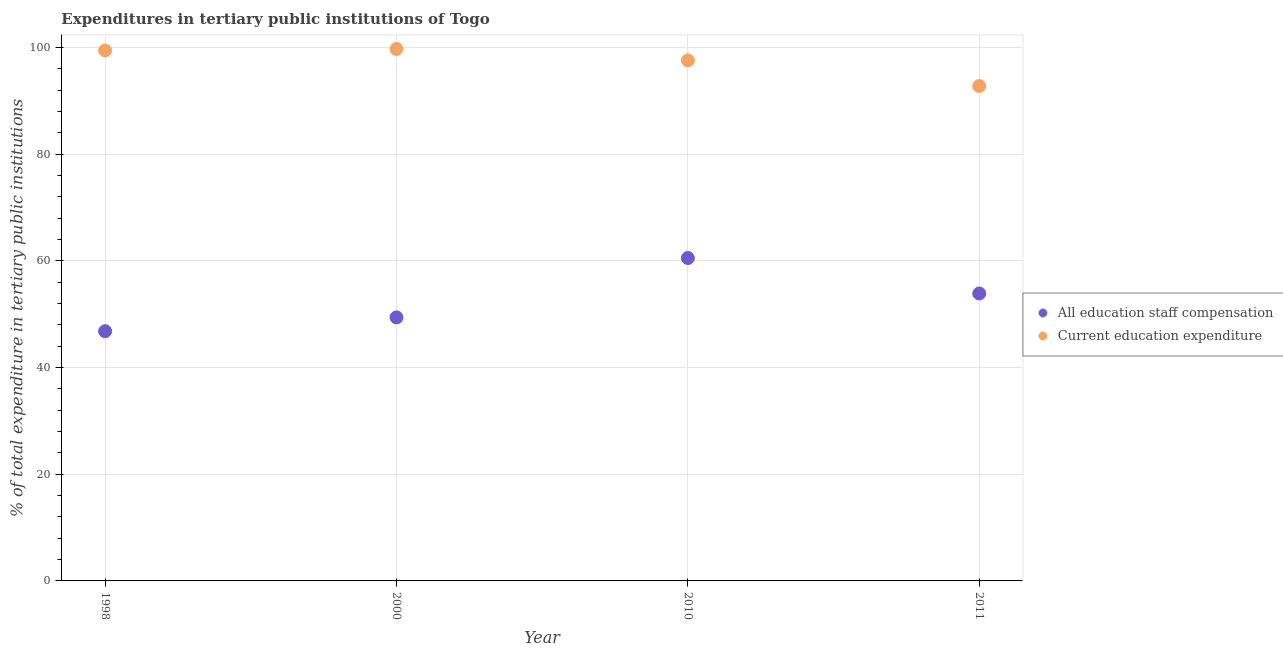What is the expenditure in education in 2000?
Ensure brevity in your answer.  99.72. Across all years, what is the maximum expenditure in education?
Ensure brevity in your answer.  99.72. Across all years, what is the minimum expenditure in education?
Your answer should be compact. 92.78. In which year was the expenditure in education maximum?
Keep it short and to the point. 2000. What is the total expenditure in staff compensation in the graph?
Ensure brevity in your answer.  210.64. What is the difference between the expenditure in staff compensation in 1998 and that in 2000?
Your response must be concise. -2.59. What is the difference between the expenditure in staff compensation in 2010 and the expenditure in education in 1998?
Your answer should be compact. -38.91. What is the average expenditure in education per year?
Your answer should be compact. 97.38. In the year 2010, what is the difference between the expenditure in staff compensation and expenditure in education?
Keep it short and to the point. -37.06. In how many years, is the expenditure in education greater than 88 %?
Give a very brief answer. 4. What is the ratio of the expenditure in staff compensation in 2000 to that in 2011?
Offer a very short reply. 0.92. Is the difference between the expenditure in education in 1998 and 2000 greater than the difference between the expenditure in staff compensation in 1998 and 2000?
Your answer should be compact. Yes. What is the difference between the highest and the second highest expenditure in education?
Your answer should be compact. 0.28. What is the difference between the highest and the lowest expenditure in education?
Ensure brevity in your answer.  6.95. Is the sum of the expenditure in education in 2000 and 2010 greater than the maximum expenditure in staff compensation across all years?
Make the answer very short. Yes. Is the expenditure in education strictly greater than the expenditure in staff compensation over the years?
Give a very brief answer. Yes. What is the difference between two consecutive major ticks on the Y-axis?
Make the answer very short. 20. Are the values on the major ticks of Y-axis written in scientific E-notation?
Your answer should be compact. No. Does the graph contain any zero values?
Make the answer very short. No. Does the graph contain grids?
Give a very brief answer. Yes. What is the title of the graph?
Your response must be concise. Expenditures in tertiary public institutions of Togo. Does "Private funds" appear as one of the legend labels in the graph?
Provide a short and direct response. No. What is the label or title of the Y-axis?
Offer a very short reply. % of total expenditure in tertiary public institutions. What is the % of total expenditure in tertiary public institutions in All education staff compensation in 1998?
Keep it short and to the point. 46.81. What is the % of total expenditure in tertiary public institutions of Current education expenditure in 1998?
Provide a short and direct response. 99.45. What is the % of total expenditure in tertiary public institutions in All education staff compensation in 2000?
Give a very brief answer. 49.4. What is the % of total expenditure in tertiary public institutions in Current education expenditure in 2000?
Give a very brief answer. 99.72. What is the % of total expenditure in tertiary public institutions of All education staff compensation in 2010?
Give a very brief answer. 60.53. What is the % of total expenditure in tertiary public institutions in Current education expenditure in 2010?
Offer a terse response. 97.59. What is the % of total expenditure in tertiary public institutions in All education staff compensation in 2011?
Provide a short and direct response. 53.89. What is the % of total expenditure in tertiary public institutions of Current education expenditure in 2011?
Your response must be concise. 92.78. Across all years, what is the maximum % of total expenditure in tertiary public institutions in All education staff compensation?
Offer a terse response. 60.53. Across all years, what is the maximum % of total expenditure in tertiary public institutions in Current education expenditure?
Your response must be concise. 99.72. Across all years, what is the minimum % of total expenditure in tertiary public institutions of All education staff compensation?
Your response must be concise. 46.81. Across all years, what is the minimum % of total expenditure in tertiary public institutions of Current education expenditure?
Give a very brief answer. 92.78. What is the total % of total expenditure in tertiary public institutions in All education staff compensation in the graph?
Your response must be concise. 210.64. What is the total % of total expenditure in tertiary public institutions in Current education expenditure in the graph?
Give a very brief answer. 389.54. What is the difference between the % of total expenditure in tertiary public institutions in All education staff compensation in 1998 and that in 2000?
Offer a very short reply. -2.59. What is the difference between the % of total expenditure in tertiary public institutions in Current education expenditure in 1998 and that in 2000?
Your response must be concise. -0.28. What is the difference between the % of total expenditure in tertiary public institutions in All education staff compensation in 1998 and that in 2010?
Your answer should be compact. -13.72. What is the difference between the % of total expenditure in tertiary public institutions of Current education expenditure in 1998 and that in 2010?
Make the answer very short. 1.85. What is the difference between the % of total expenditure in tertiary public institutions in All education staff compensation in 1998 and that in 2011?
Your answer should be compact. -7.08. What is the difference between the % of total expenditure in tertiary public institutions of Current education expenditure in 1998 and that in 2011?
Keep it short and to the point. 6.67. What is the difference between the % of total expenditure in tertiary public institutions of All education staff compensation in 2000 and that in 2010?
Ensure brevity in your answer.  -11.13. What is the difference between the % of total expenditure in tertiary public institutions in Current education expenditure in 2000 and that in 2010?
Offer a terse response. 2.13. What is the difference between the % of total expenditure in tertiary public institutions of All education staff compensation in 2000 and that in 2011?
Keep it short and to the point. -4.48. What is the difference between the % of total expenditure in tertiary public institutions of Current education expenditure in 2000 and that in 2011?
Offer a terse response. 6.95. What is the difference between the % of total expenditure in tertiary public institutions of All education staff compensation in 2010 and that in 2011?
Your response must be concise. 6.64. What is the difference between the % of total expenditure in tertiary public institutions in Current education expenditure in 2010 and that in 2011?
Provide a short and direct response. 4.81. What is the difference between the % of total expenditure in tertiary public institutions of All education staff compensation in 1998 and the % of total expenditure in tertiary public institutions of Current education expenditure in 2000?
Your answer should be very brief. -52.91. What is the difference between the % of total expenditure in tertiary public institutions in All education staff compensation in 1998 and the % of total expenditure in tertiary public institutions in Current education expenditure in 2010?
Give a very brief answer. -50.78. What is the difference between the % of total expenditure in tertiary public institutions of All education staff compensation in 1998 and the % of total expenditure in tertiary public institutions of Current education expenditure in 2011?
Ensure brevity in your answer.  -45.97. What is the difference between the % of total expenditure in tertiary public institutions in All education staff compensation in 2000 and the % of total expenditure in tertiary public institutions in Current education expenditure in 2010?
Ensure brevity in your answer.  -48.19. What is the difference between the % of total expenditure in tertiary public institutions in All education staff compensation in 2000 and the % of total expenditure in tertiary public institutions in Current education expenditure in 2011?
Make the answer very short. -43.37. What is the difference between the % of total expenditure in tertiary public institutions of All education staff compensation in 2010 and the % of total expenditure in tertiary public institutions of Current education expenditure in 2011?
Your answer should be compact. -32.24. What is the average % of total expenditure in tertiary public institutions of All education staff compensation per year?
Provide a succinct answer. 52.66. What is the average % of total expenditure in tertiary public institutions in Current education expenditure per year?
Your answer should be very brief. 97.38. In the year 1998, what is the difference between the % of total expenditure in tertiary public institutions in All education staff compensation and % of total expenditure in tertiary public institutions in Current education expenditure?
Provide a short and direct response. -52.63. In the year 2000, what is the difference between the % of total expenditure in tertiary public institutions in All education staff compensation and % of total expenditure in tertiary public institutions in Current education expenditure?
Keep it short and to the point. -50.32. In the year 2010, what is the difference between the % of total expenditure in tertiary public institutions in All education staff compensation and % of total expenditure in tertiary public institutions in Current education expenditure?
Your response must be concise. -37.06. In the year 2011, what is the difference between the % of total expenditure in tertiary public institutions of All education staff compensation and % of total expenditure in tertiary public institutions of Current education expenditure?
Provide a short and direct response. -38.89. What is the ratio of the % of total expenditure in tertiary public institutions of All education staff compensation in 1998 to that in 2000?
Give a very brief answer. 0.95. What is the ratio of the % of total expenditure in tertiary public institutions of Current education expenditure in 1998 to that in 2000?
Offer a terse response. 1. What is the ratio of the % of total expenditure in tertiary public institutions of All education staff compensation in 1998 to that in 2010?
Provide a succinct answer. 0.77. What is the ratio of the % of total expenditure in tertiary public institutions of Current education expenditure in 1998 to that in 2010?
Offer a very short reply. 1.02. What is the ratio of the % of total expenditure in tertiary public institutions of All education staff compensation in 1998 to that in 2011?
Ensure brevity in your answer.  0.87. What is the ratio of the % of total expenditure in tertiary public institutions of Current education expenditure in 1998 to that in 2011?
Your answer should be compact. 1.07. What is the ratio of the % of total expenditure in tertiary public institutions in All education staff compensation in 2000 to that in 2010?
Keep it short and to the point. 0.82. What is the ratio of the % of total expenditure in tertiary public institutions of Current education expenditure in 2000 to that in 2010?
Your response must be concise. 1.02. What is the ratio of the % of total expenditure in tertiary public institutions of All education staff compensation in 2000 to that in 2011?
Provide a short and direct response. 0.92. What is the ratio of the % of total expenditure in tertiary public institutions of Current education expenditure in 2000 to that in 2011?
Your answer should be compact. 1.07. What is the ratio of the % of total expenditure in tertiary public institutions of All education staff compensation in 2010 to that in 2011?
Offer a terse response. 1.12. What is the ratio of the % of total expenditure in tertiary public institutions of Current education expenditure in 2010 to that in 2011?
Your answer should be compact. 1.05. What is the difference between the highest and the second highest % of total expenditure in tertiary public institutions of All education staff compensation?
Provide a short and direct response. 6.64. What is the difference between the highest and the second highest % of total expenditure in tertiary public institutions in Current education expenditure?
Your answer should be compact. 0.28. What is the difference between the highest and the lowest % of total expenditure in tertiary public institutions of All education staff compensation?
Provide a short and direct response. 13.72. What is the difference between the highest and the lowest % of total expenditure in tertiary public institutions in Current education expenditure?
Provide a short and direct response. 6.95. 